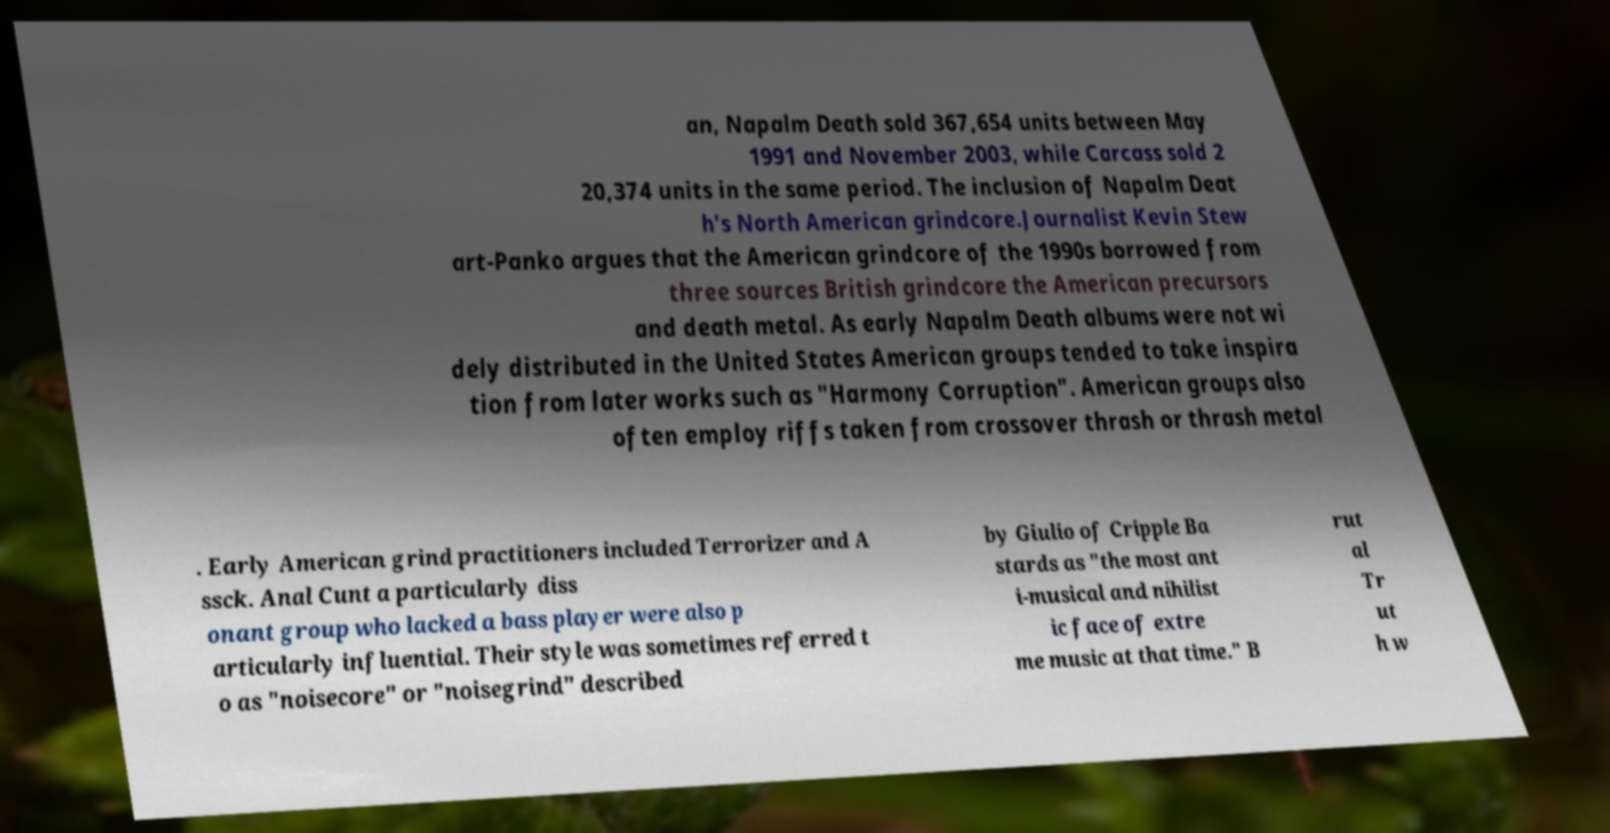Please identify and transcribe the text found in this image. an, Napalm Death sold 367,654 units between May 1991 and November 2003, while Carcass sold 2 20,374 units in the same period. The inclusion of Napalm Deat h's North American grindcore.Journalist Kevin Stew art-Panko argues that the American grindcore of the 1990s borrowed from three sources British grindcore the American precursors and death metal. As early Napalm Death albums were not wi dely distributed in the United States American groups tended to take inspira tion from later works such as "Harmony Corruption". American groups also often employ riffs taken from crossover thrash or thrash metal . Early American grind practitioners included Terrorizer and A ssck. Anal Cunt a particularly diss onant group who lacked a bass player were also p articularly influential. Their style was sometimes referred t o as "noisecore" or "noisegrind" described by Giulio of Cripple Ba stards as "the most ant i-musical and nihilist ic face of extre me music at that time." B rut al Tr ut h w 